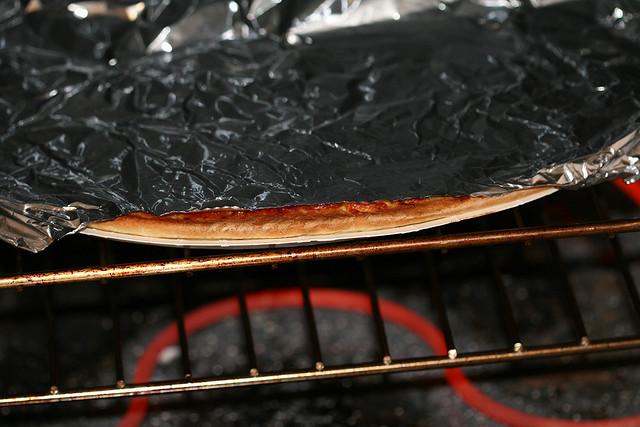Is it hot in there?
Keep it brief. Yes. Is the heating element on?
Give a very brief answer. Yes. Is the food in a glass dish?
Quick response, please. No. 